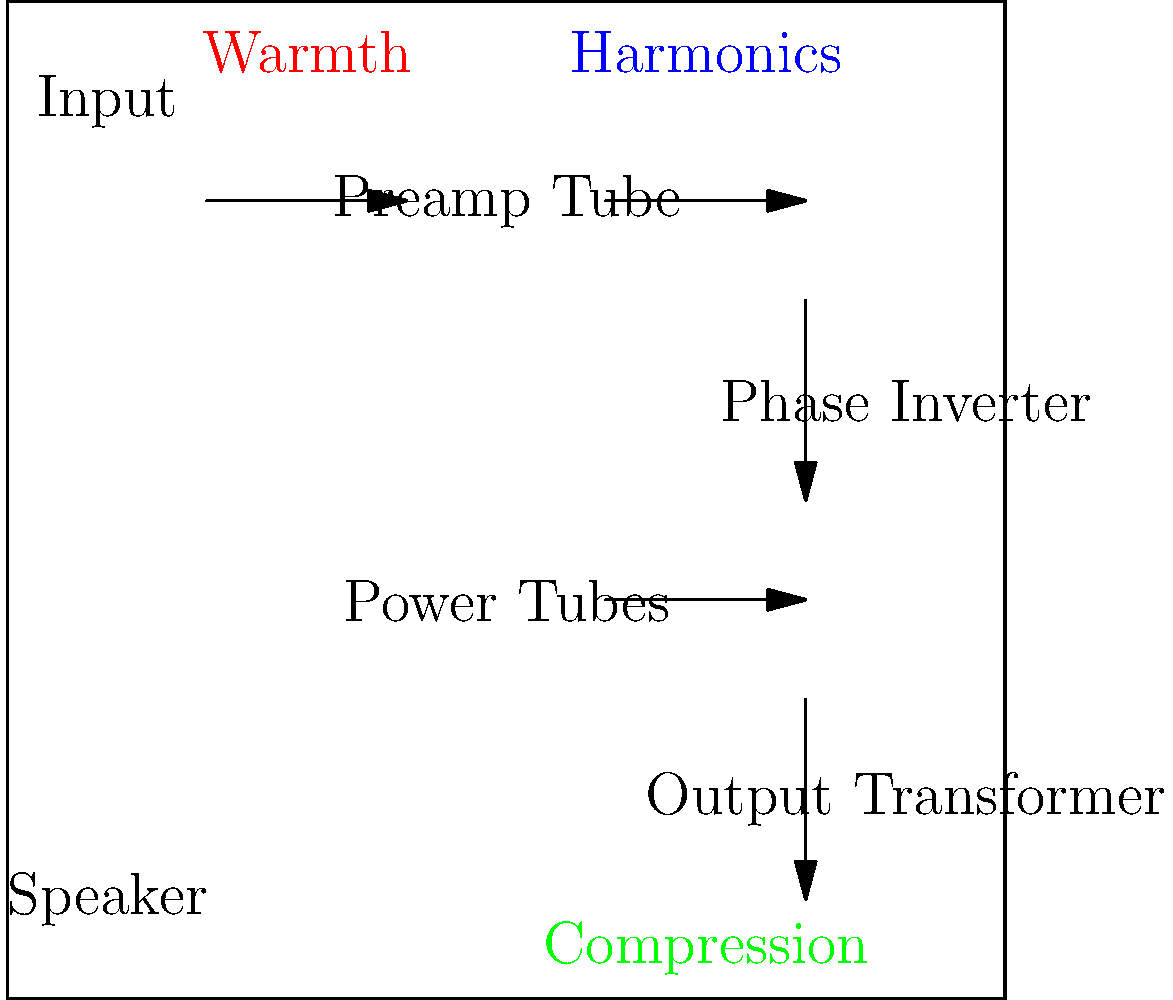In the diagram of a tube amplifier, which component is primarily responsible for adding harmonic richness to the guitar tone, a characteristic highly valued by guitarists seeking analog warmth? To answer this question, let's examine the components of a tube amplifier and their impact on tone:

1. Input: This is where the guitar signal enters the amplifier. It doesn't significantly alter the tone.

2. Preamp Tube: This is the first stage of amplification. It's crucial for shaping the initial tone and can add some harmonic content, but it's not the primary source of harmonic richness.

3. Phase Inverter: This splits the signal into two opposite phases for the power tubes. It doesn't significantly contribute to harmonic content.

4. Power Tubes: These are the main source of harmonic richness in a tube amplifier. When pushed into overdrive, power tubes generate even-order harmonics that are musically pleasing and contribute to the warm, full sound associated with tube amplifiers.

5. Output Transformer: This matches the high impedance of the power tubes to the low impedance of the speaker. It can affect the tone but doesn't generate harmonics.

6. Speaker: While important for the final sound, it doesn't generate harmonics in the same way as the amplifier components.

The power tubes, when driven hard, enter a state of "soft clipping," which rounds off the peaks of the waveform instead of sharply cutting them off. This soft clipping is what produces the even-order harmonics that give tube amplifiers their characteristic warm, rich tone.

Therefore, the power tubes are primarily responsible for adding harmonic richness to the guitar tone, which is highly valued by guitarists seeking analog warmth.
Answer: Power Tubes 